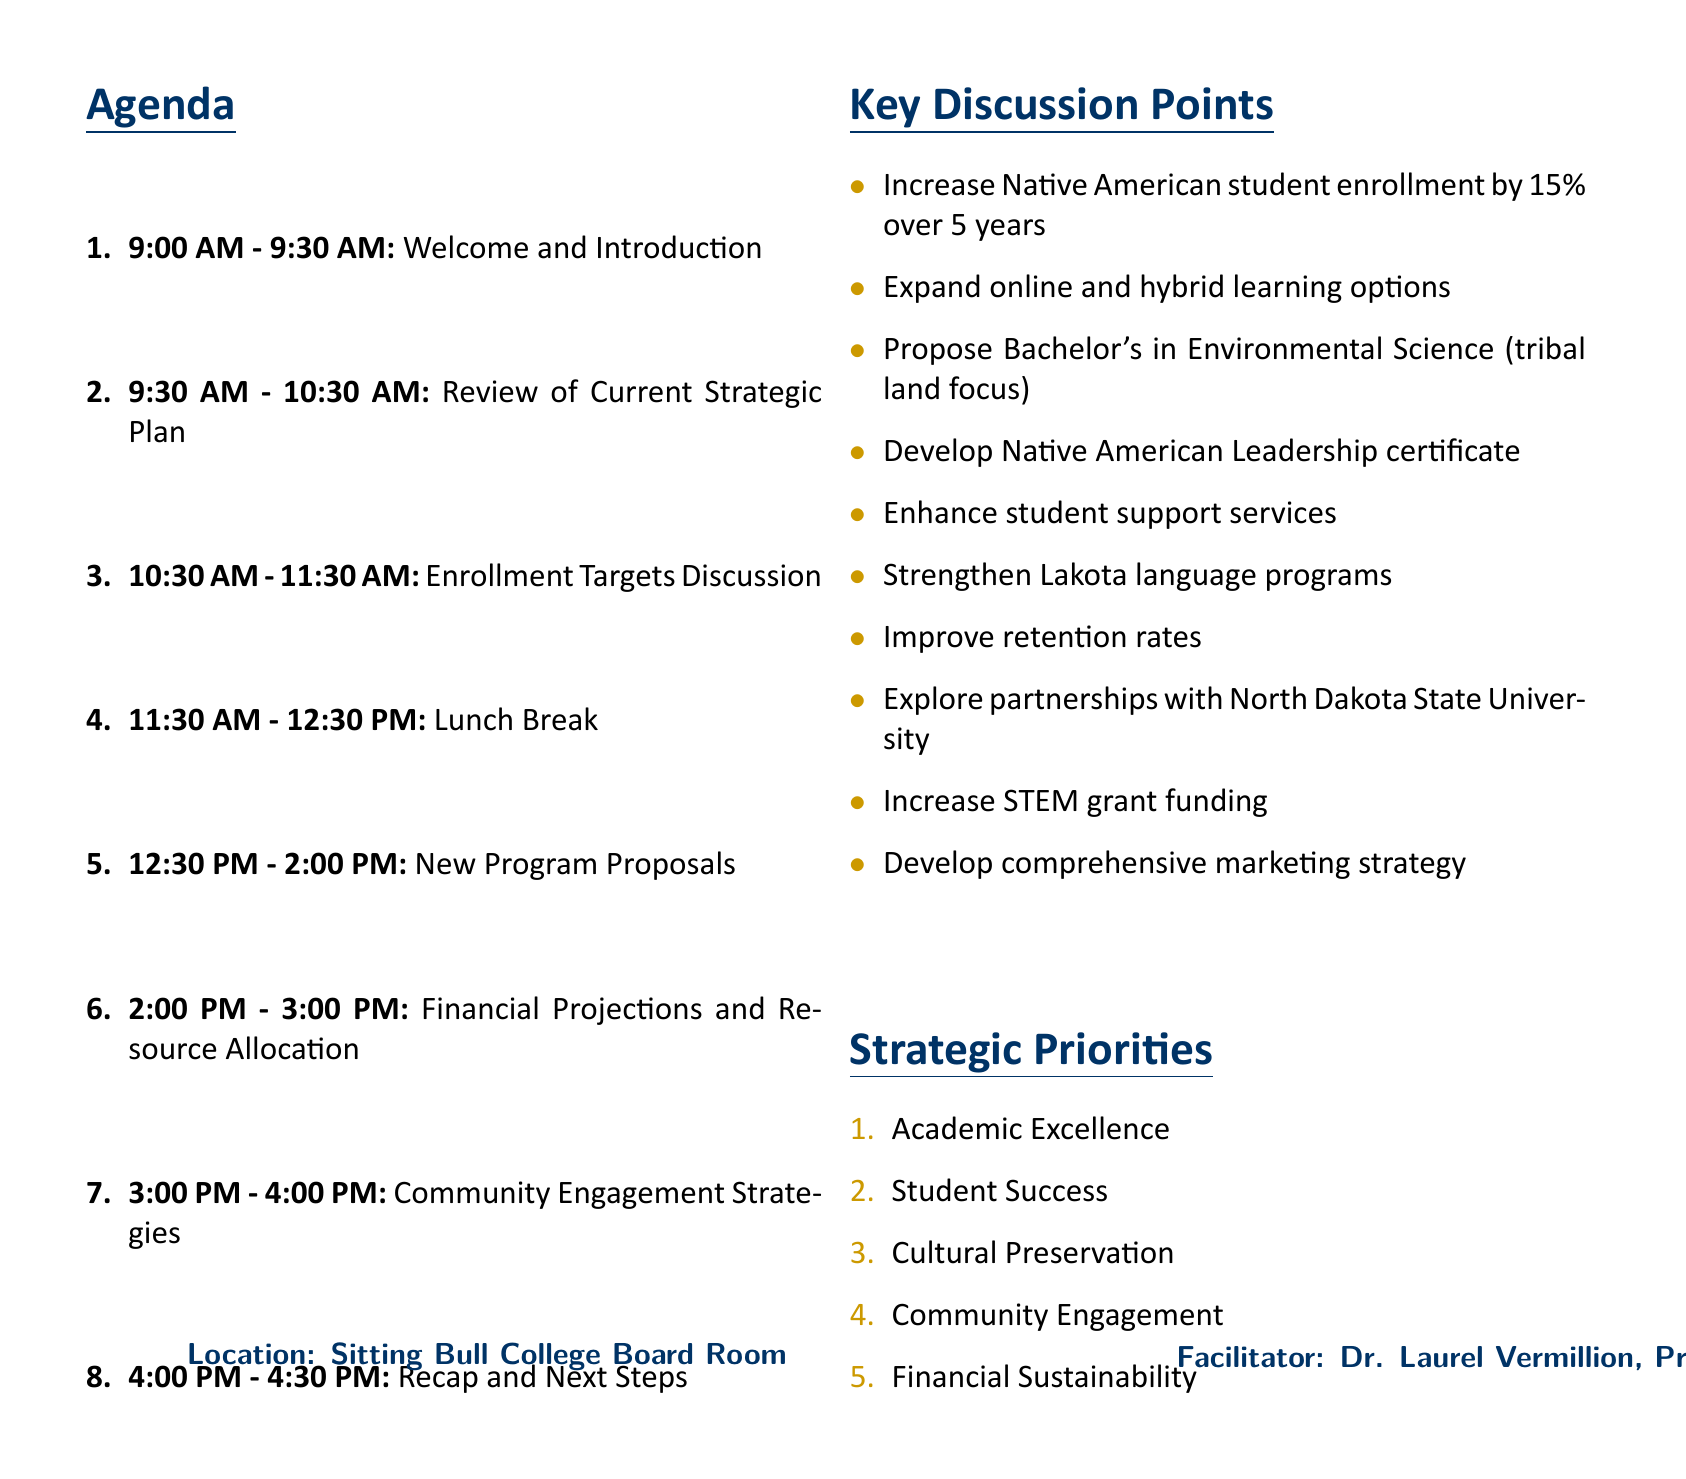what is the date of the session? The date of the session is stated clearly at the beginning of the document.
Answer: September 15, 2023 who is the facilitator of the session? The facilitator is mentioned as Dr. Laurel Vermillion in the document.
Answer: Dr. Laurel Vermillion what is the time slot for the Enrollment Targets Discussion? The time slot is given in the agenda section of the document.
Answer: 10:30 AM - 11:30 AM what is the estimated growth target for Native American student enrollment? This figure is mentioned under key discussion points in the document.
Answer: 15% how many attendees are listed for the session? The number of attendees can be counted from the list provided.
Answer: 6 what is one of the strategic priorities outlined in the document? The document lists the strategic priorities in a section dedicated to them.
Answer: Academic Excellence what is the focus of the proposed new Bachelor's degree? The focus is noted under new program proposals in the agenda.
Answer: Tribal land management what is the current enrollment number? The current enrollment figure is provided in the relevant data section of the document.
Answer: 310 what is the total value of the college's endowment? The value is stated in the relevant data section of the document.
Answer: $3.7 million what kind of lunch break is scheduled during the session? The description of the lunch break details the nature of the break available to attendees.
Answer: Networking opportunity with light refreshments provided 